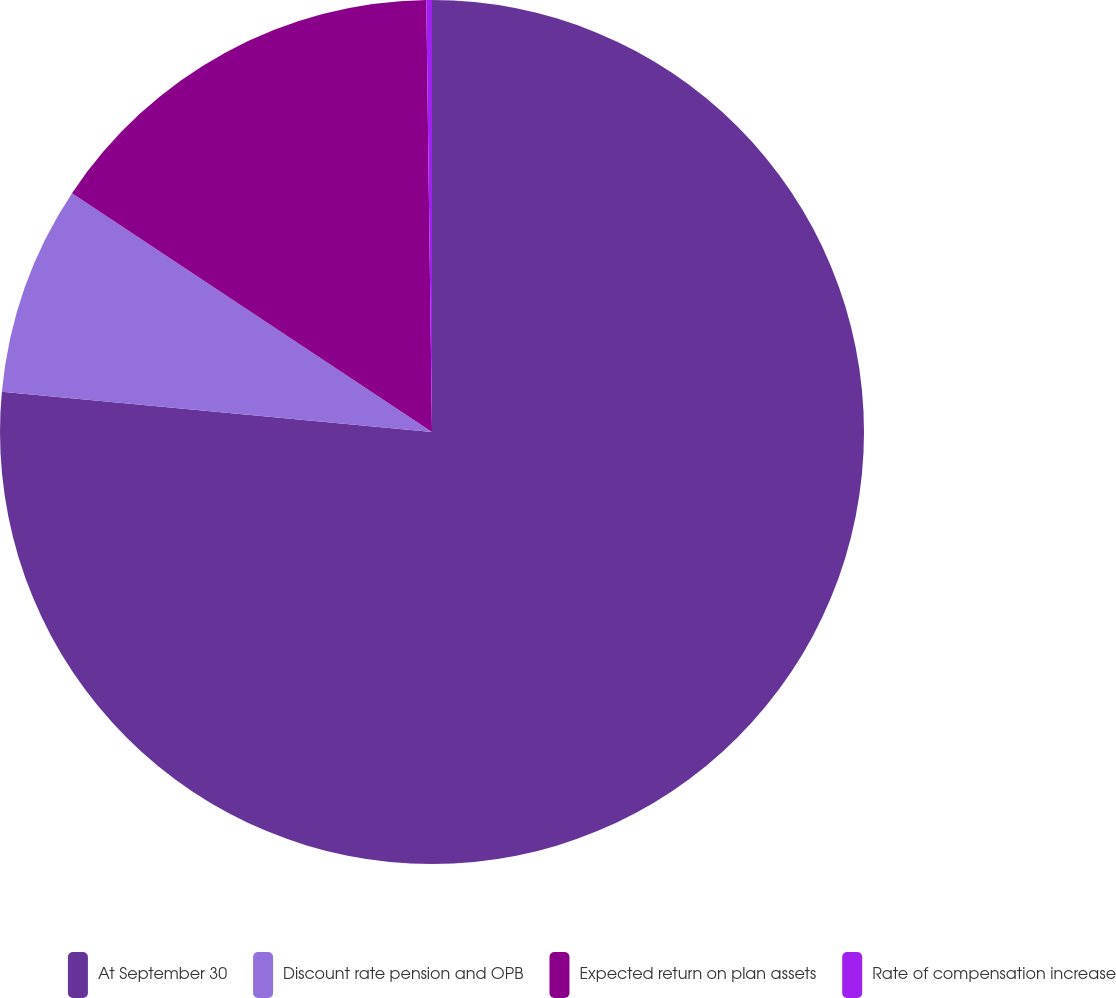Convert chart to OTSL. <chart><loc_0><loc_0><loc_500><loc_500><pie_chart><fcel>At September 30<fcel>Discount rate pension and OPB<fcel>Expected return on plan assets<fcel>Rate of compensation increase<nl><fcel>76.49%<fcel>7.84%<fcel>15.47%<fcel>0.21%<nl></chart> 